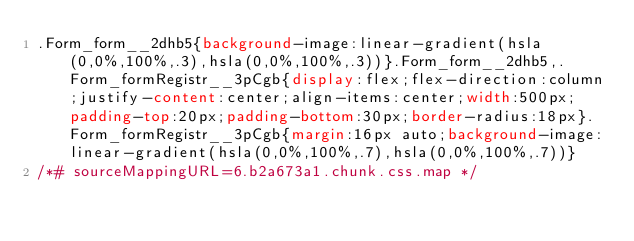<code> <loc_0><loc_0><loc_500><loc_500><_CSS_>.Form_form__2dhb5{background-image:linear-gradient(hsla(0,0%,100%,.3),hsla(0,0%,100%,.3))}.Form_form__2dhb5,.Form_formRegistr__3pCgb{display:flex;flex-direction:column;justify-content:center;align-items:center;width:500px;padding-top:20px;padding-bottom:30px;border-radius:18px}.Form_formRegistr__3pCgb{margin:16px auto;background-image:linear-gradient(hsla(0,0%,100%,.7),hsla(0,0%,100%,.7))}
/*# sourceMappingURL=6.b2a673a1.chunk.css.map */</code> 